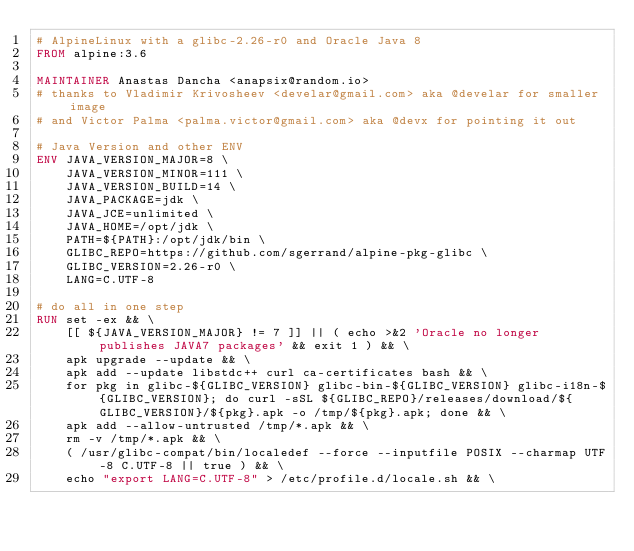Convert code to text. <code><loc_0><loc_0><loc_500><loc_500><_Dockerfile_># AlpineLinux with a glibc-2.26-r0 and Oracle Java 8
FROM alpine:3.6

MAINTAINER Anastas Dancha <anapsix@random.io>
# thanks to Vladimir Krivosheev <develar@gmail.com> aka @develar for smaller image
# and Victor Palma <palma.victor@gmail.com> aka @devx for pointing it out

# Java Version and other ENV
ENV JAVA_VERSION_MAJOR=8 \
    JAVA_VERSION_MINOR=111 \
    JAVA_VERSION_BUILD=14 \
    JAVA_PACKAGE=jdk \
    JAVA_JCE=unlimited \
    JAVA_HOME=/opt/jdk \
    PATH=${PATH}:/opt/jdk/bin \
    GLIBC_REPO=https://github.com/sgerrand/alpine-pkg-glibc \
    GLIBC_VERSION=2.26-r0 \
    LANG=C.UTF-8

# do all in one step
RUN set -ex && \
    [[ ${JAVA_VERSION_MAJOR} != 7 ]] || ( echo >&2 'Oracle no longer publishes JAVA7 packages' && exit 1 ) && \
    apk upgrade --update && \
    apk add --update libstdc++ curl ca-certificates bash && \
    for pkg in glibc-${GLIBC_VERSION} glibc-bin-${GLIBC_VERSION} glibc-i18n-${GLIBC_VERSION}; do curl -sSL ${GLIBC_REPO}/releases/download/${GLIBC_VERSION}/${pkg}.apk -o /tmp/${pkg}.apk; done && \
    apk add --allow-untrusted /tmp/*.apk && \
    rm -v /tmp/*.apk && \
    ( /usr/glibc-compat/bin/localedef --force --inputfile POSIX --charmap UTF-8 C.UTF-8 || true ) && \
    echo "export LANG=C.UTF-8" > /etc/profile.d/locale.sh && \</code> 